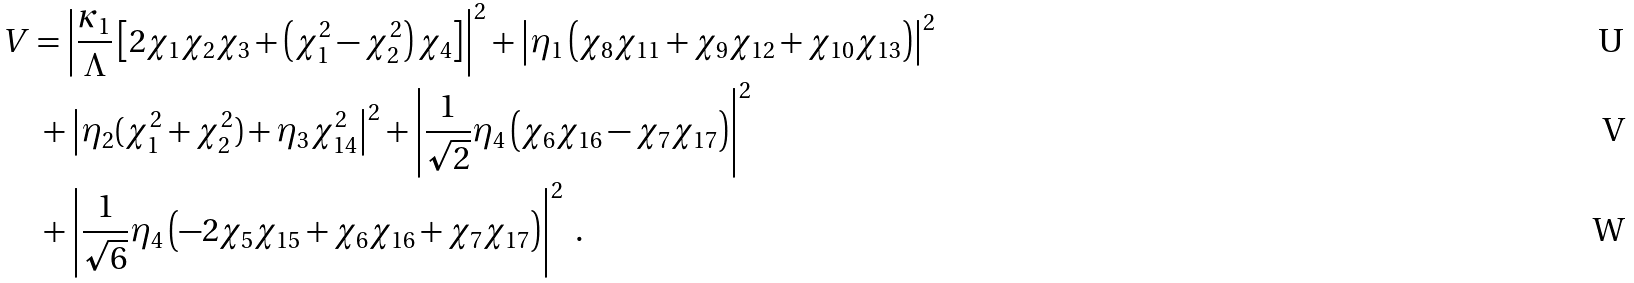Convert formula to latex. <formula><loc_0><loc_0><loc_500><loc_500>V & = \left | \frac { \kappa _ { 1 } } { \Lambda } \left [ 2 \chi _ { 1 } \chi _ { 2 } \chi _ { 3 } + \left ( \chi _ { 1 } ^ { 2 } - \chi _ { 2 } ^ { 2 } \right ) \chi _ { 4 } \right ] \right | ^ { 2 } + \left | \eta _ { 1 } \left ( \chi _ { 8 } \chi _ { 1 1 } + \chi _ { 9 } \chi _ { 1 2 } + \chi _ { 1 0 } \chi _ { 1 3 } \right ) \right | ^ { 2 } \\ & \ + \left | \eta _ { 2 } ( \chi _ { 1 } ^ { 2 } + \chi _ { 2 } ^ { 2 } ) + \eta _ { 3 } \chi _ { 1 4 } ^ { 2 } \right | ^ { 2 } + \left | \frac { 1 } { \sqrt { 2 } } \eta _ { 4 } \left ( \chi _ { 6 } \chi _ { 1 6 } - \chi _ { 7 } \chi _ { 1 7 } \right ) \right | ^ { 2 } \\ & \ + \left | \frac { 1 } { \sqrt { 6 } } \eta _ { 4 } \left ( - 2 \chi _ { 5 } \chi _ { 1 5 } + \chi _ { 6 } \chi _ { 1 6 } + \chi _ { 7 } \chi _ { 1 7 } \right ) \right | ^ { 2 } \ .</formula> 